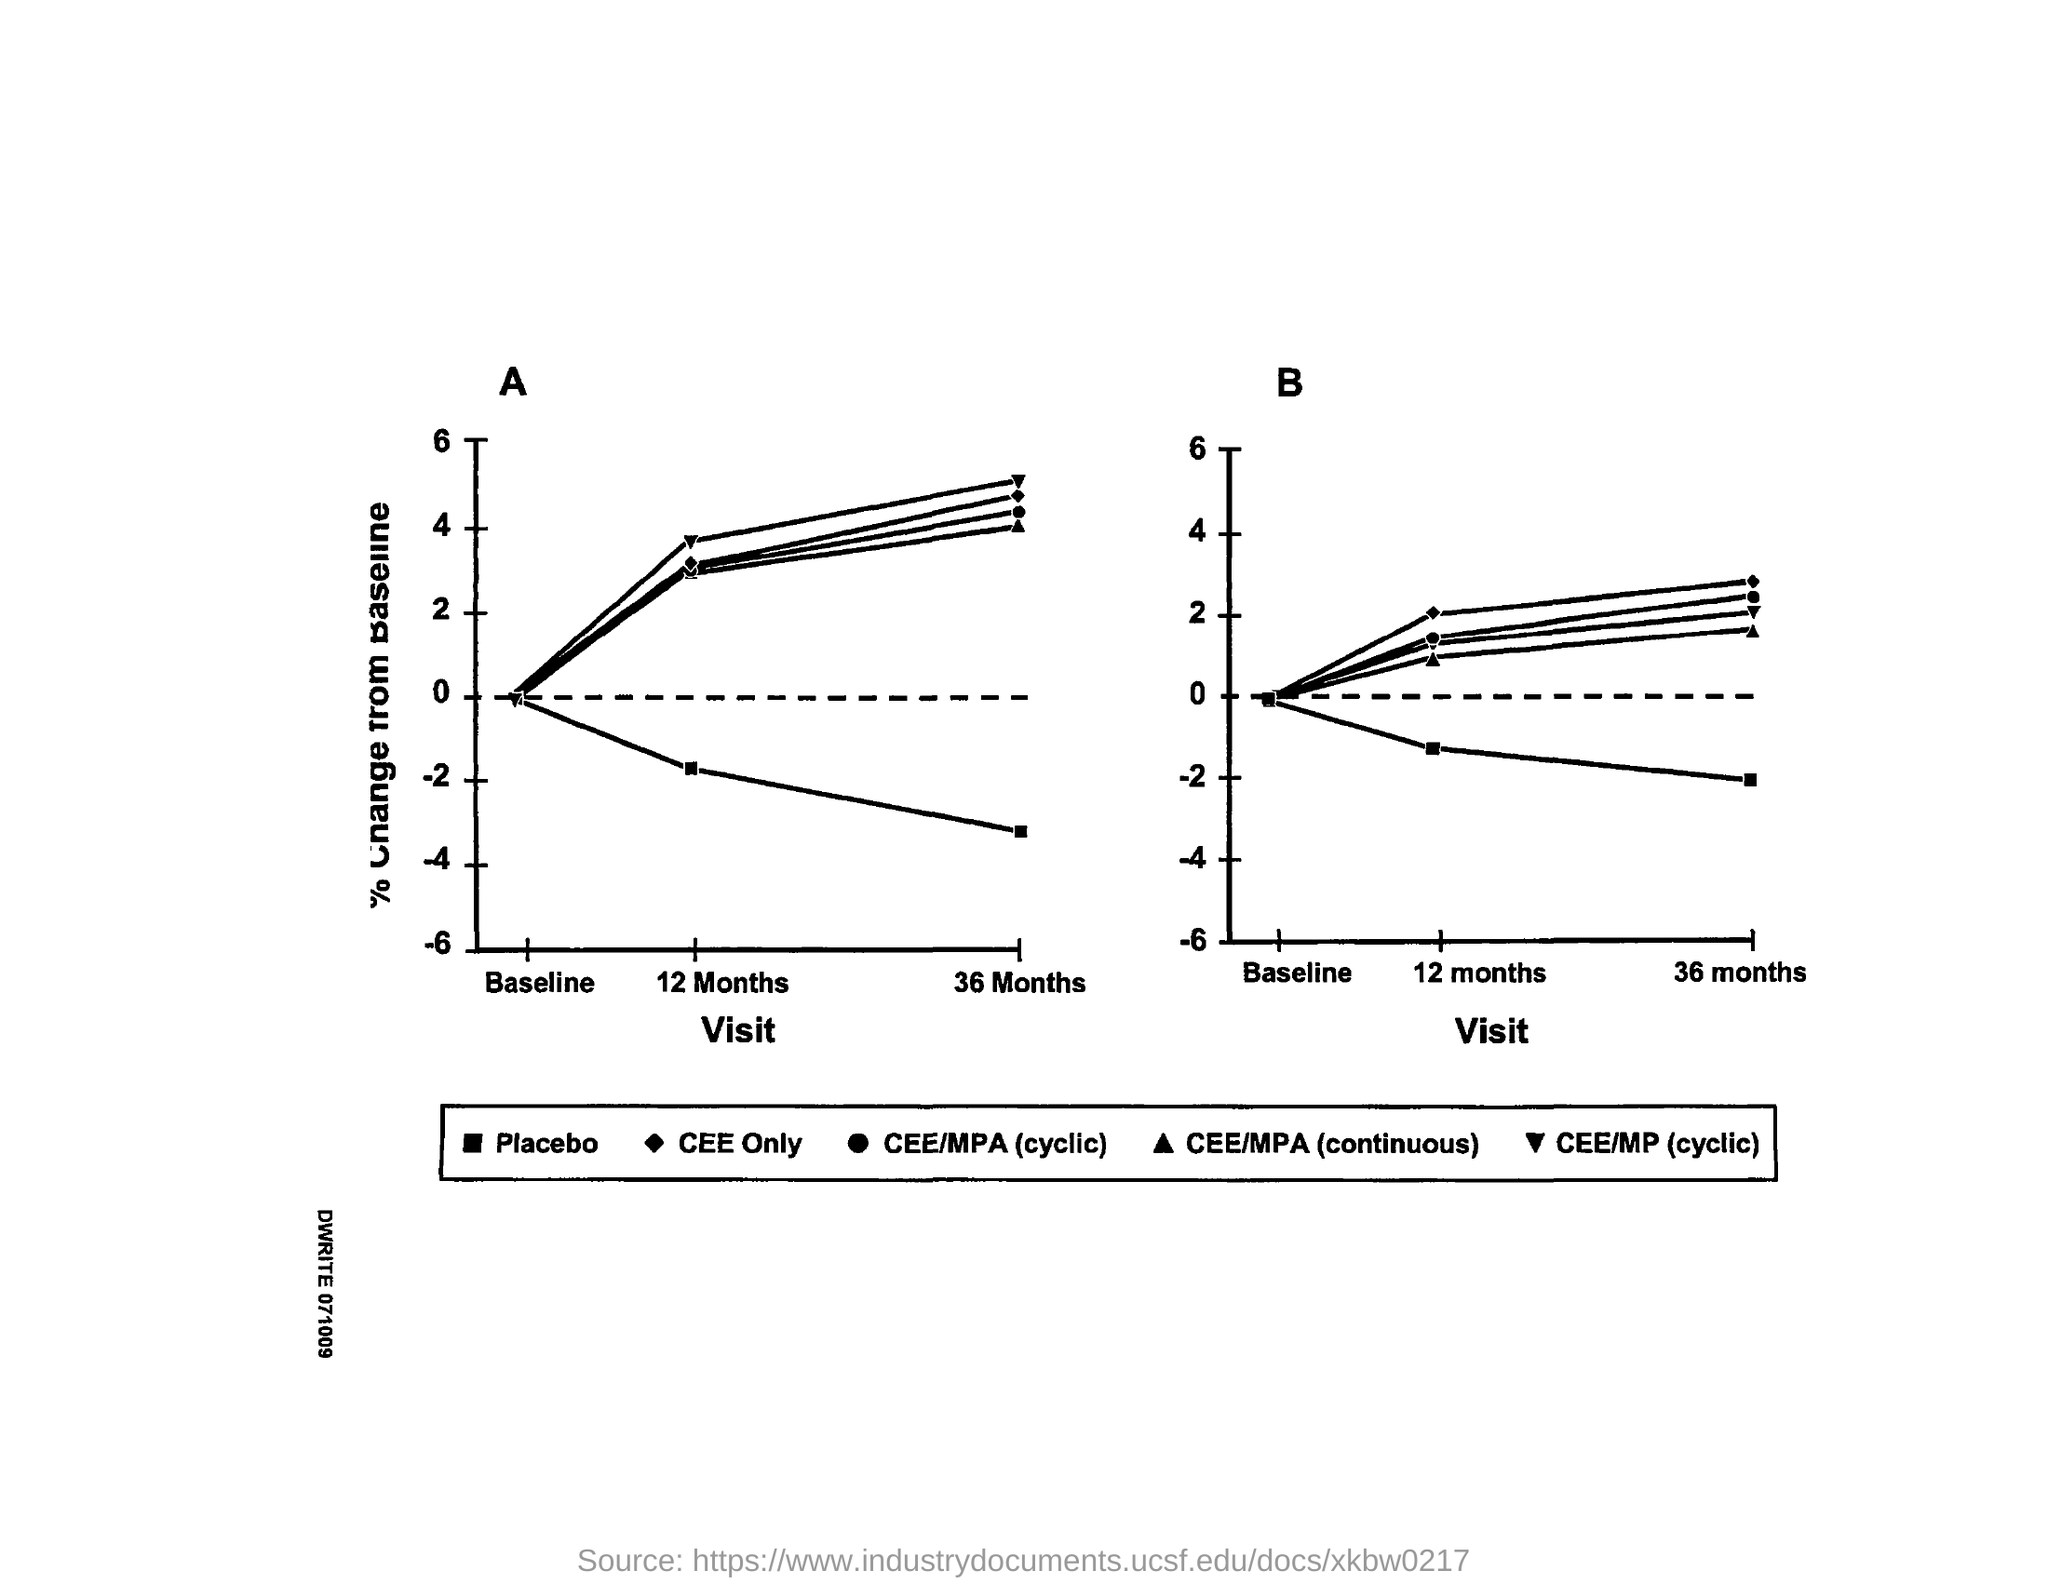Point out several critical features in this image. The second graph is represented by the letter "B. Both graphs plot the value of visit on the x-axis. The first graph is represented by the alphabet 'A.' 